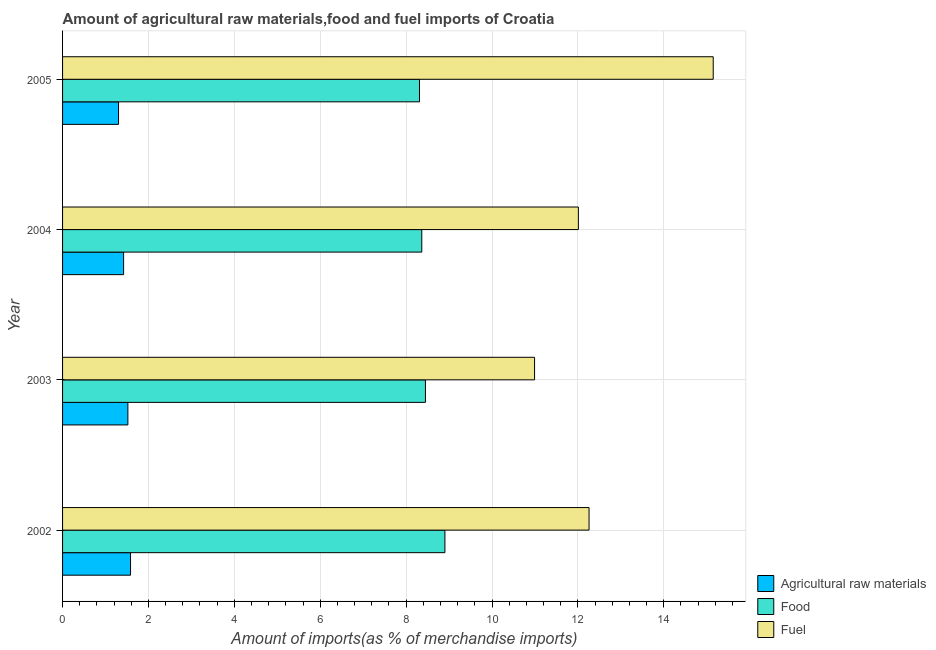How many different coloured bars are there?
Provide a succinct answer. 3. How many groups of bars are there?
Provide a short and direct response. 4. Are the number of bars on each tick of the Y-axis equal?
Provide a succinct answer. Yes. How many bars are there on the 4th tick from the bottom?
Give a very brief answer. 3. What is the label of the 1st group of bars from the top?
Give a very brief answer. 2005. What is the percentage of food imports in 2002?
Provide a succinct answer. 8.9. Across all years, what is the maximum percentage of raw materials imports?
Keep it short and to the point. 1.58. Across all years, what is the minimum percentage of food imports?
Ensure brevity in your answer.  8.31. What is the total percentage of fuel imports in the graph?
Offer a very short reply. 50.41. What is the difference between the percentage of fuel imports in 2004 and that in 2005?
Give a very brief answer. -3.14. What is the difference between the percentage of raw materials imports in 2004 and the percentage of food imports in 2005?
Ensure brevity in your answer.  -6.89. What is the average percentage of fuel imports per year?
Offer a terse response. 12.6. In the year 2002, what is the difference between the percentage of food imports and percentage of fuel imports?
Ensure brevity in your answer.  -3.36. In how many years, is the percentage of fuel imports greater than 7.2 %?
Offer a terse response. 4. What is the ratio of the percentage of raw materials imports in 2003 to that in 2005?
Ensure brevity in your answer.  1.17. Is the difference between the percentage of raw materials imports in 2003 and 2004 greater than the difference between the percentage of fuel imports in 2003 and 2004?
Keep it short and to the point. Yes. What is the difference between the highest and the second highest percentage of fuel imports?
Your response must be concise. 2.89. What is the difference between the highest and the lowest percentage of food imports?
Provide a succinct answer. 0.59. Is the sum of the percentage of raw materials imports in 2002 and 2004 greater than the maximum percentage of fuel imports across all years?
Your answer should be very brief. No. What does the 1st bar from the top in 2002 represents?
Ensure brevity in your answer.  Fuel. What does the 2nd bar from the bottom in 2003 represents?
Ensure brevity in your answer.  Food. Is it the case that in every year, the sum of the percentage of raw materials imports and percentage of food imports is greater than the percentage of fuel imports?
Keep it short and to the point. No. Are all the bars in the graph horizontal?
Your answer should be very brief. Yes. What is the difference between two consecutive major ticks on the X-axis?
Give a very brief answer. 2. Are the values on the major ticks of X-axis written in scientific E-notation?
Your response must be concise. No. Does the graph contain any zero values?
Ensure brevity in your answer.  No. Does the graph contain grids?
Give a very brief answer. Yes. Where does the legend appear in the graph?
Offer a terse response. Bottom right. How many legend labels are there?
Provide a succinct answer. 3. What is the title of the graph?
Make the answer very short. Amount of agricultural raw materials,food and fuel imports of Croatia. Does "Natural Gas" appear as one of the legend labels in the graph?
Make the answer very short. No. What is the label or title of the X-axis?
Your response must be concise. Amount of imports(as % of merchandise imports). What is the Amount of imports(as % of merchandise imports) of Agricultural raw materials in 2002?
Make the answer very short. 1.58. What is the Amount of imports(as % of merchandise imports) in Food in 2002?
Your answer should be very brief. 8.9. What is the Amount of imports(as % of merchandise imports) of Fuel in 2002?
Make the answer very short. 12.26. What is the Amount of imports(as % of merchandise imports) in Agricultural raw materials in 2003?
Offer a very short reply. 1.52. What is the Amount of imports(as % of merchandise imports) in Food in 2003?
Keep it short and to the point. 8.45. What is the Amount of imports(as % of merchandise imports) of Fuel in 2003?
Provide a short and direct response. 10.99. What is the Amount of imports(as % of merchandise imports) in Agricultural raw materials in 2004?
Ensure brevity in your answer.  1.42. What is the Amount of imports(as % of merchandise imports) of Food in 2004?
Provide a succinct answer. 8.36. What is the Amount of imports(as % of merchandise imports) in Fuel in 2004?
Provide a succinct answer. 12.01. What is the Amount of imports(as % of merchandise imports) of Agricultural raw materials in 2005?
Give a very brief answer. 1.3. What is the Amount of imports(as % of merchandise imports) in Food in 2005?
Give a very brief answer. 8.31. What is the Amount of imports(as % of merchandise imports) in Fuel in 2005?
Your answer should be very brief. 15.15. Across all years, what is the maximum Amount of imports(as % of merchandise imports) in Agricultural raw materials?
Your response must be concise. 1.58. Across all years, what is the maximum Amount of imports(as % of merchandise imports) in Food?
Give a very brief answer. 8.9. Across all years, what is the maximum Amount of imports(as % of merchandise imports) in Fuel?
Provide a succinct answer. 15.15. Across all years, what is the minimum Amount of imports(as % of merchandise imports) in Agricultural raw materials?
Offer a terse response. 1.3. Across all years, what is the minimum Amount of imports(as % of merchandise imports) of Food?
Ensure brevity in your answer.  8.31. Across all years, what is the minimum Amount of imports(as % of merchandise imports) of Fuel?
Your response must be concise. 10.99. What is the total Amount of imports(as % of merchandise imports) in Agricultural raw materials in the graph?
Provide a short and direct response. 5.83. What is the total Amount of imports(as % of merchandise imports) in Food in the graph?
Make the answer very short. 34.03. What is the total Amount of imports(as % of merchandise imports) of Fuel in the graph?
Make the answer very short. 50.41. What is the difference between the Amount of imports(as % of merchandise imports) in Agricultural raw materials in 2002 and that in 2003?
Ensure brevity in your answer.  0.06. What is the difference between the Amount of imports(as % of merchandise imports) of Food in 2002 and that in 2003?
Give a very brief answer. 0.45. What is the difference between the Amount of imports(as % of merchandise imports) in Fuel in 2002 and that in 2003?
Keep it short and to the point. 1.27. What is the difference between the Amount of imports(as % of merchandise imports) of Agricultural raw materials in 2002 and that in 2004?
Give a very brief answer. 0.16. What is the difference between the Amount of imports(as % of merchandise imports) of Food in 2002 and that in 2004?
Make the answer very short. 0.54. What is the difference between the Amount of imports(as % of merchandise imports) in Fuel in 2002 and that in 2004?
Keep it short and to the point. 0.25. What is the difference between the Amount of imports(as % of merchandise imports) in Agricultural raw materials in 2002 and that in 2005?
Your answer should be compact. 0.28. What is the difference between the Amount of imports(as % of merchandise imports) of Food in 2002 and that in 2005?
Provide a succinct answer. 0.59. What is the difference between the Amount of imports(as % of merchandise imports) in Fuel in 2002 and that in 2005?
Your answer should be compact. -2.89. What is the difference between the Amount of imports(as % of merchandise imports) of Agricultural raw materials in 2003 and that in 2004?
Provide a succinct answer. 0.1. What is the difference between the Amount of imports(as % of merchandise imports) in Food in 2003 and that in 2004?
Offer a very short reply. 0.09. What is the difference between the Amount of imports(as % of merchandise imports) of Fuel in 2003 and that in 2004?
Give a very brief answer. -1.02. What is the difference between the Amount of imports(as % of merchandise imports) in Agricultural raw materials in 2003 and that in 2005?
Keep it short and to the point. 0.22. What is the difference between the Amount of imports(as % of merchandise imports) of Food in 2003 and that in 2005?
Provide a short and direct response. 0.14. What is the difference between the Amount of imports(as % of merchandise imports) in Fuel in 2003 and that in 2005?
Offer a terse response. -4.16. What is the difference between the Amount of imports(as % of merchandise imports) in Agricultural raw materials in 2004 and that in 2005?
Your answer should be compact. 0.12. What is the difference between the Amount of imports(as % of merchandise imports) in Food in 2004 and that in 2005?
Give a very brief answer. 0.05. What is the difference between the Amount of imports(as % of merchandise imports) of Fuel in 2004 and that in 2005?
Provide a short and direct response. -3.14. What is the difference between the Amount of imports(as % of merchandise imports) of Agricultural raw materials in 2002 and the Amount of imports(as % of merchandise imports) of Food in 2003?
Your answer should be very brief. -6.87. What is the difference between the Amount of imports(as % of merchandise imports) in Agricultural raw materials in 2002 and the Amount of imports(as % of merchandise imports) in Fuel in 2003?
Your answer should be compact. -9.41. What is the difference between the Amount of imports(as % of merchandise imports) in Food in 2002 and the Amount of imports(as % of merchandise imports) in Fuel in 2003?
Provide a succinct answer. -2.09. What is the difference between the Amount of imports(as % of merchandise imports) of Agricultural raw materials in 2002 and the Amount of imports(as % of merchandise imports) of Food in 2004?
Offer a terse response. -6.78. What is the difference between the Amount of imports(as % of merchandise imports) of Agricultural raw materials in 2002 and the Amount of imports(as % of merchandise imports) of Fuel in 2004?
Provide a succinct answer. -10.43. What is the difference between the Amount of imports(as % of merchandise imports) in Food in 2002 and the Amount of imports(as % of merchandise imports) in Fuel in 2004?
Give a very brief answer. -3.11. What is the difference between the Amount of imports(as % of merchandise imports) of Agricultural raw materials in 2002 and the Amount of imports(as % of merchandise imports) of Food in 2005?
Give a very brief answer. -6.73. What is the difference between the Amount of imports(as % of merchandise imports) in Agricultural raw materials in 2002 and the Amount of imports(as % of merchandise imports) in Fuel in 2005?
Offer a very short reply. -13.57. What is the difference between the Amount of imports(as % of merchandise imports) of Food in 2002 and the Amount of imports(as % of merchandise imports) of Fuel in 2005?
Make the answer very short. -6.25. What is the difference between the Amount of imports(as % of merchandise imports) of Agricultural raw materials in 2003 and the Amount of imports(as % of merchandise imports) of Food in 2004?
Keep it short and to the point. -6.84. What is the difference between the Amount of imports(as % of merchandise imports) of Agricultural raw materials in 2003 and the Amount of imports(as % of merchandise imports) of Fuel in 2004?
Give a very brief answer. -10.49. What is the difference between the Amount of imports(as % of merchandise imports) of Food in 2003 and the Amount of imports(as % of merchandise imports) of Fuel in 2004?
Offer a very short reply. -3.56. What is the difference between the Amount of imports(as % of merchandise imports) in Agricultural raw materials in 2003 and the Amount of imports(as % of merchandise imports) in Food in 2005?
Keep it short and to the point. -6.79. What is the difference between the Amount of imports(as % of merchandise imports) of Agricultural raw materials in 2003 and the Amount of imports(as % of merchandise imports) of Fuel in 2005?
Offer a very short reply. -13.63. What is the difference between the Amount of imports(as % of merchandise imports) of Food in 2003 and the Amount of imports(as % of merchandise imports) of Fuel in 2005?
Your response must be concise. -6.7. What is the difference between the Amount of imports(as % of merchandise imports) in Agricultural raw materials in 2004 and the Amount of imports(as % of merchandise imports) in Food in 2005?
Your response must be concise. -6.89. What is the difference between the Amount of imports(as % of merchandise imports) in Agricultural raw materials in 2004 and the Amount of imports(as % of merchandise imports) in Fuel in 2005?
Provide a short and direct response. -13.73. What is the difference between the Amount of imports(as % of merchandise imports) in Food in 2004 and the Amount of imports(as % of merchandise imports) in Fuel in 2005?
Offer a very short reply. -6.79. What is the average Amount of imports(as % of merchandise imports) of Agricultural raw materials per year?
Provide a short and direct response. 1.46. What is the average Amount of imports(as % of merchandise imports) in Food per year?
Ensure brevity in your answer.  8.51. What is the average Amount of imports(as % of merchandise imports) in Fuel per year?
Give a very brief answer. 12.6. In the year 2002, what is the difference between the Amount of imports(as % of merchandise imports) in Agricultural raw materials and Amount of imports(as % of merchandise imports) in Food?
Keep it short and to the point. -7.32. In the year 2002, what is the difference between the Amount of imports(as % of merchandise imports) in Agricultural raw materials and Amount of imports(as % of merchandise imports) in Fuel?
Offer a terse response. -10.68. In the year 2002, what is the difference between the Amount of imports(as % of merchandise imports) of Food and Amount of imports(as % of merchandise imports) of Fuel?
Give a very brief answer. -3.36. In the year 2003, what is the difference between the Amount of imports(as % of merchandise imports) of Agricultural raw materials and Amount of imports(as % of merchandise imports) of Food?
Keep it short and to the point. -6.93. In the year 2003, what is the difference between the Amount of imports(as % of merchandise imports) of Agricultural raw materials and Amount of imports(as % of merchandise imports) of Fuel?
Give a very brief answer. -9.47. In the year 2003, what is the difference between the Amount of imports(as % of merchandise imports) of Food and Amount of imports(as % of merchandise imports) of Fuel?
Keep it short and to the point. -2.54. In the year 2004, what is the difference between the Amount of imports(as % of merchandise imports) in Agricultural raw materials and Amount of imports(as % of merchandise imports) in Food?
Offer a terse response. -6.94. In the year 2004, what is the difference between the Amount of imports(as % of merchandise imports) of Agricultural raw materials and Amount of imports(as % of merchandise imports) of Fuel?
Offer a very short reply. -10.59. In the year 2004, what is the difference between the Amount of imports(as % of merchandise imports) in Food and Amount of imports(as % of merchandise imports) in Fuel?
Ensure brevity in your answer.  -3.65. In the year 2005, what is the difference between the Amount of imports(as % of merchandise imports) of Agricultural raw materials and Amount of imports(as % of merchandise imports) of Food?
Your answer should be compact. -7.01. In the year 2005, what is the difference between the Amount of imports(as % of merchandise imports) in Agricultural raw materials and Amount of imports(as % of merchandise imports) in Fuel?
Make the answer very short. -13.85. In the year 2005, what is the difference between the Amount of imports(as % of merchandise imports) of Food and Amount of imports(as % of merchandise imports) of Fuel?
Give a very brief answer. -6.84. What is the ratio of the Amount of imports(as % of merchandise imports) of Agricultural raw materials in 2002 to that in 2003?
Offer a terse response. 1.04. What is the ratio of the Amount of imports(as % of merchandise imports) of Food in 2002 to that in 2003?
Provide a short and direct response. 1.05. What is the ratio of the Amount of imports(as % of merchandise imports) of Fuel in 2002 to that in 2003?
Your answer should be very brief. 1.12. What is the ratio of the Amount of imports(as % of merchandise imports) in Agricultural raw materials in 2002 to that in 2004?
Your answer should be compact. 1.11. What is the ratio of the Amount of imports(as % of merchandise imports) of Food in 2002 to that in 2004?
Offer a very short reply. 1.06. What is the ratio of the Amount of imports(as % of merchandise imports) in Fuel in 2002 to that in 2004?
Provide a succinct answer. 1.02. What is the ratio of the Amount of imports(as % of merchandise imports) in Agricultural raw materials in 2002 to that in 2005?
Give a very brief answer. 1.21. What is the ratio of the Amount of imports(as % of merchandise imports) of Food in 2002 to that in 2005?
Make the answer very short. 1.07. What is the ratio of the Amount of imports(as % of merchandise imports) of Fuel in 2002 to that in 2005?
Provide a succinct answer. 0.81. What is the ratio of the Amount of imports(as % of merchandise imports) in Agricultural raw materials in 2003 to that in 2004?
Offer a terse response. 1.07. What is the ratio of the Amount of imports(as % of merchandise imports) of Food in 2003 to that in 2004?
Your response must be concise. 1.01. What is the ratio of the Amount of imports(as % of merchandise imports) of Fuel in 2003 to that in 2004?
Your answer should be compact. 0.92. What is the ratio of the Amount of imports(as % of merchandise imports) in Agricultural raw materials in 2003 to that in 2005?
Your answer should be very brief. 1.17. What is the ratio of the Amount of imports(as % of merchandise imports) in Food in 2003 to that in 2005?
Give a very brief answer. 1.02. What is the ratio of the Amount of imports(as % of merchandise imports) in Fuel in 2003 to that in 2005?
Offer a terse response. 0.73. What is the ratio of the Amount of imports(as % of merchandise imports) in Agricultural raw materials in 2004 to that in 2005?
Provide a short and direct response. 1.09. What is the ratio of the Amount of imports(as % of merchandise imports) of Food in 2004 to that in 2005?
Ensure brevity in your answer.  1.01. What is the ratio of the Amount of imports(as % of merchandise imports) in Fuel in 2004 to that in 2005?
Provide a short and direct response. 0.79. What is the difference between the highest and the second highest Amount of imports(as % of merchandise imports) in Agricultural raw materials?
Your response must be concise. 0.06. What is the difference between the highest and the second highest Amount of imports(as % of merchandise imports) of Food?
Your response must be concise. 0.45. What is the difference between the highest and the second highest Amount of imports(as % of merchandise imports) of Fuel?
Offer a terse response. 2.89. What is the difference between the highest and the lowest Amount of imports(as % of merchandise imports) of Agricultural raw materials?
Your answer should be very brief. 0.28. What is the difference between the highest and the lowest Amount of imports(as % of merchandise imports) of Food?
Your answer should be compact. 0.59. What is the difference between the highest and the lowest Amount of imports(as % of merchandise imports) in Fuel?
Your response must be concise. 4.16. 